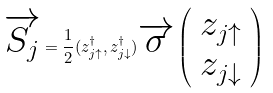<formula> <loc_0><loc_0><loc_500><loc_500>\overrightarrow { S _ { j } } = \frac { 1 } { 2 } ( z ^ { \dag } _ { j \uparrow } , { z ^ { \dag } _ { j \downarrow } } ) \overrightarrow { \sigma } \left ( \begin{array} { c } z _ { j \uparrow } \\ z _ { j \downarrow } \end{array} \right )</formula> 